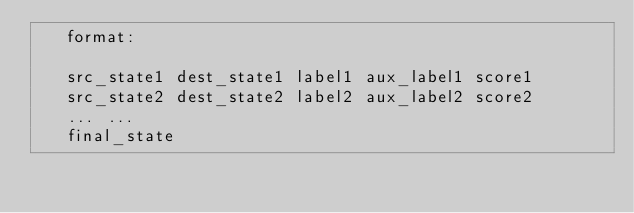Convert code to text. <code><loc_0><loc_0><loc_500><loc_500><_Cuda_>   format:

   src_state1 dest_state1 label1 aux_label1 score1
   src_state2 dest_state2 label2 aux_label2 score2
   ... ...
   final_state
</code> 